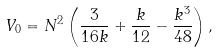<formula> <loc_0><loc_0><loc_500><loc_500>V _ { 0 } = N ^ { 2 } \left ( \frac { 3 } { 1 6 k } + \frac { k } { 1 2 } - \frac { k ^ { 3 } } { 4 8 } \right ) ,</formula> 